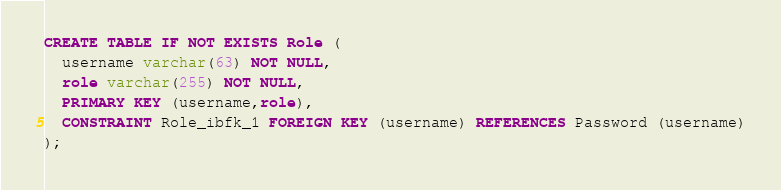Convert code to text. <code><loc_0><loc_0><loc_500><loc_500><_SQL_>CREATE TABLE IF NOT EXISTS Role (
  username varchar(63) NOT NULL,
  role varchar(255) NOT NULL,
  PRIMARY KEY (username,role),
  CONSTRAINT Role_ibfk_1 FOREIGN KEY (username) REFERENCES Password (username)
);</code> 